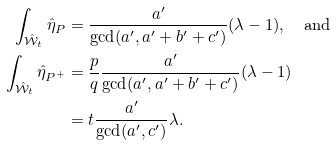Convert formula to latex. <formula><loc_0><loc_0><loc_500><loc_500>\int _ { \hat { \mathcal { W } } _ { t } } \hat { \eta } _ { P } & = \frac { a ^ { \prime } } { \gcd ( a ^ { \prime } , a ^ { \prime } + b ^ { \prime } + c ^ { \prime } ) } ( \lambda - 1 ) , \quad \text {and} \\ \int _ { \hat { \mathcal { W } } _ { t } } \hat { \eta } _ { P ^ { + } } & = \frac { p } { q } \frac { a ^ { \prime } } { \gcd ( a ^ { \prime } , a ^ { \prime } + b ^ { \prime } + c ^ { \prime } ) } ( \lambda - 1 ) \\ & = t \frac { a ^ { \prime } } { \gcd ( a ^ { \prime } , c ^ { \prime } ) } \lambda .</formula> 